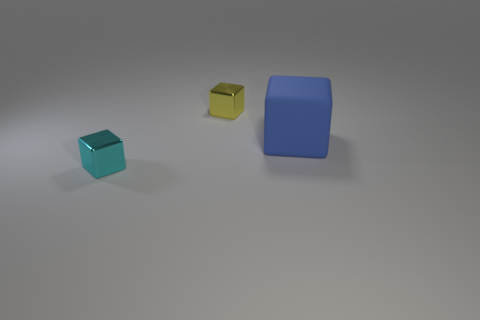What number of other objects are there of the same size as the blue matte object?
Provide a short and direct response. 0. There is a cube that is to the left of the yellow metallic cube; is its size the same as the blue rubber block behind the cyan object?
Your answer should be very brief. No. What number of things are either cyan blocks or objects to the left of the big blue cube?
Offer a very short reply. 2. There is a block that is in front of the large blue block; what is its size?
Make the answer very short. Small. Are there fewer big blue cubes to the left of the cyan cube than big blue things to the right of the large thing?
Your answer should be very brief. No. There is a block that is both behind the small cyan object and to the left of the blue matte thing; what material is it?
Make the answer very short. Metal. What number of cyan objects are either metal objects or metallic spheres?
Provide a short and direct response. 1. Are there any big blocks on the right side of the tiny yellow metal cube?
Make the answer very short. Yes. The blue cube is what size?
Your answer should be compact. Large. There is a cyan metallic object that is the same shape as the blue rubber object; what is its size?
Offer a very short reply. Small. 